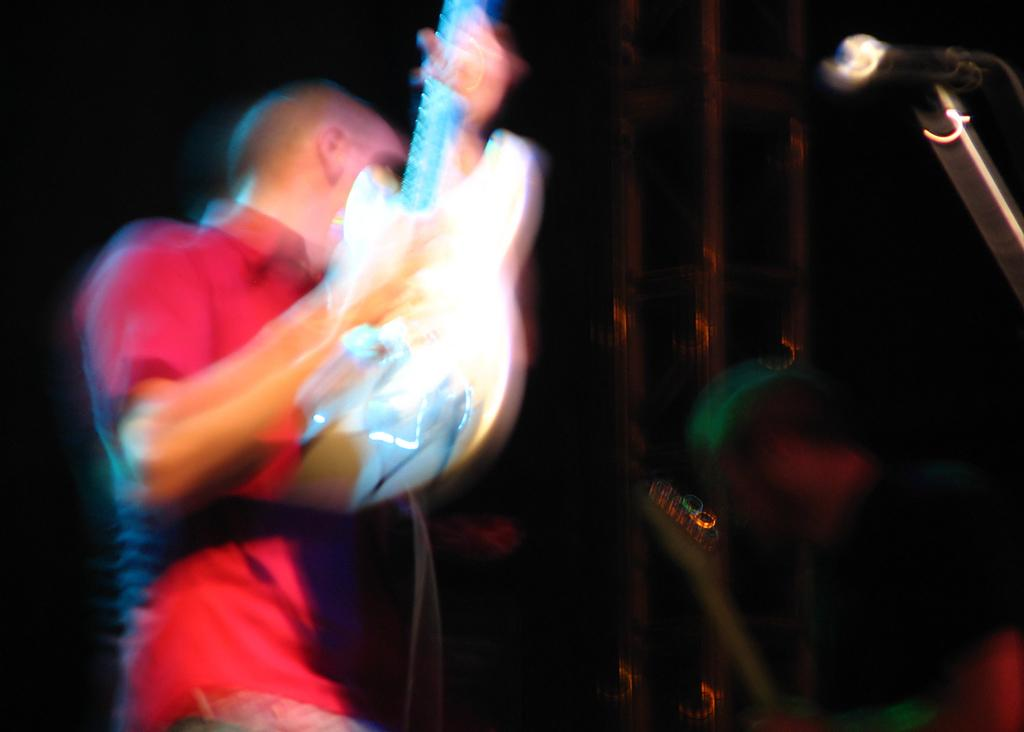What is the man in the image holding? The man is holding a guitar. Can you describe the man's activity in the image? The man appears to be playing or holding the guitar, possibly performing music. What can be seen in the background of the image? There are other persons visible in the background of the image, although they are blurry. What type of kite is the man flying in the image? There is no kite present in the image; the man is holding a guitar. Is the man a passenger in a vehicle in the image? There is no indication of a vehicle or the man being a passenger in the image; he is holding a guitar. 